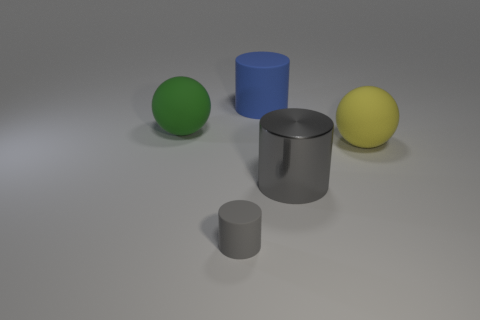Do the yellow rubber object and the matte cylinder in front of the large yellow matte sphere have the same size? While both objects have a yellow hue, they do not have the same size. The yellow rubber object, which appears smaller and could be a ball, is situated farther away from the viewpoint than the matte grey cylinder in the foreground. Due to the perspective, it's difficult to compare their sizes directly, but the cylinder's proximity makes it appear larger. 